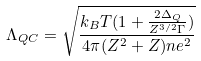Convert formula to latex. <formula><loc_0><loc_0><loc_500><loc_500>\Lambda _ { Q C } = \sqrt { \frac { k _ { B } T ( 1 + \frac { 2 \Delta _ { Q } } { Z ^ { 3 / 2 } \Gamma } ) } { 4 \pi ( Z ^ { 2 } + Z ) n e ^ { 2 } } }</formula> 